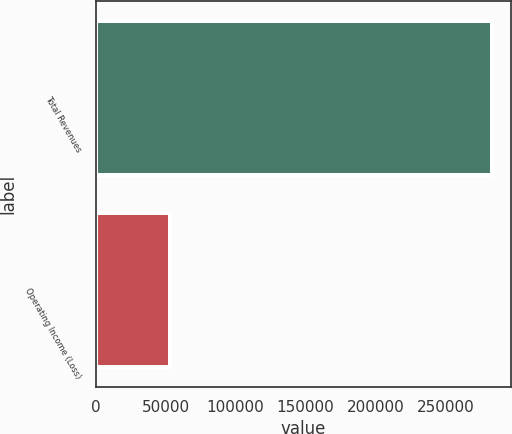Convert chart to OTSL. <chart><loc_0><loc_0><loc_500><loc_500><bar_chart><fcel>Total Revenues<fcel>Operating Income (Loss)<nl><fcel>283142<fcel>53071<nl></chart> 